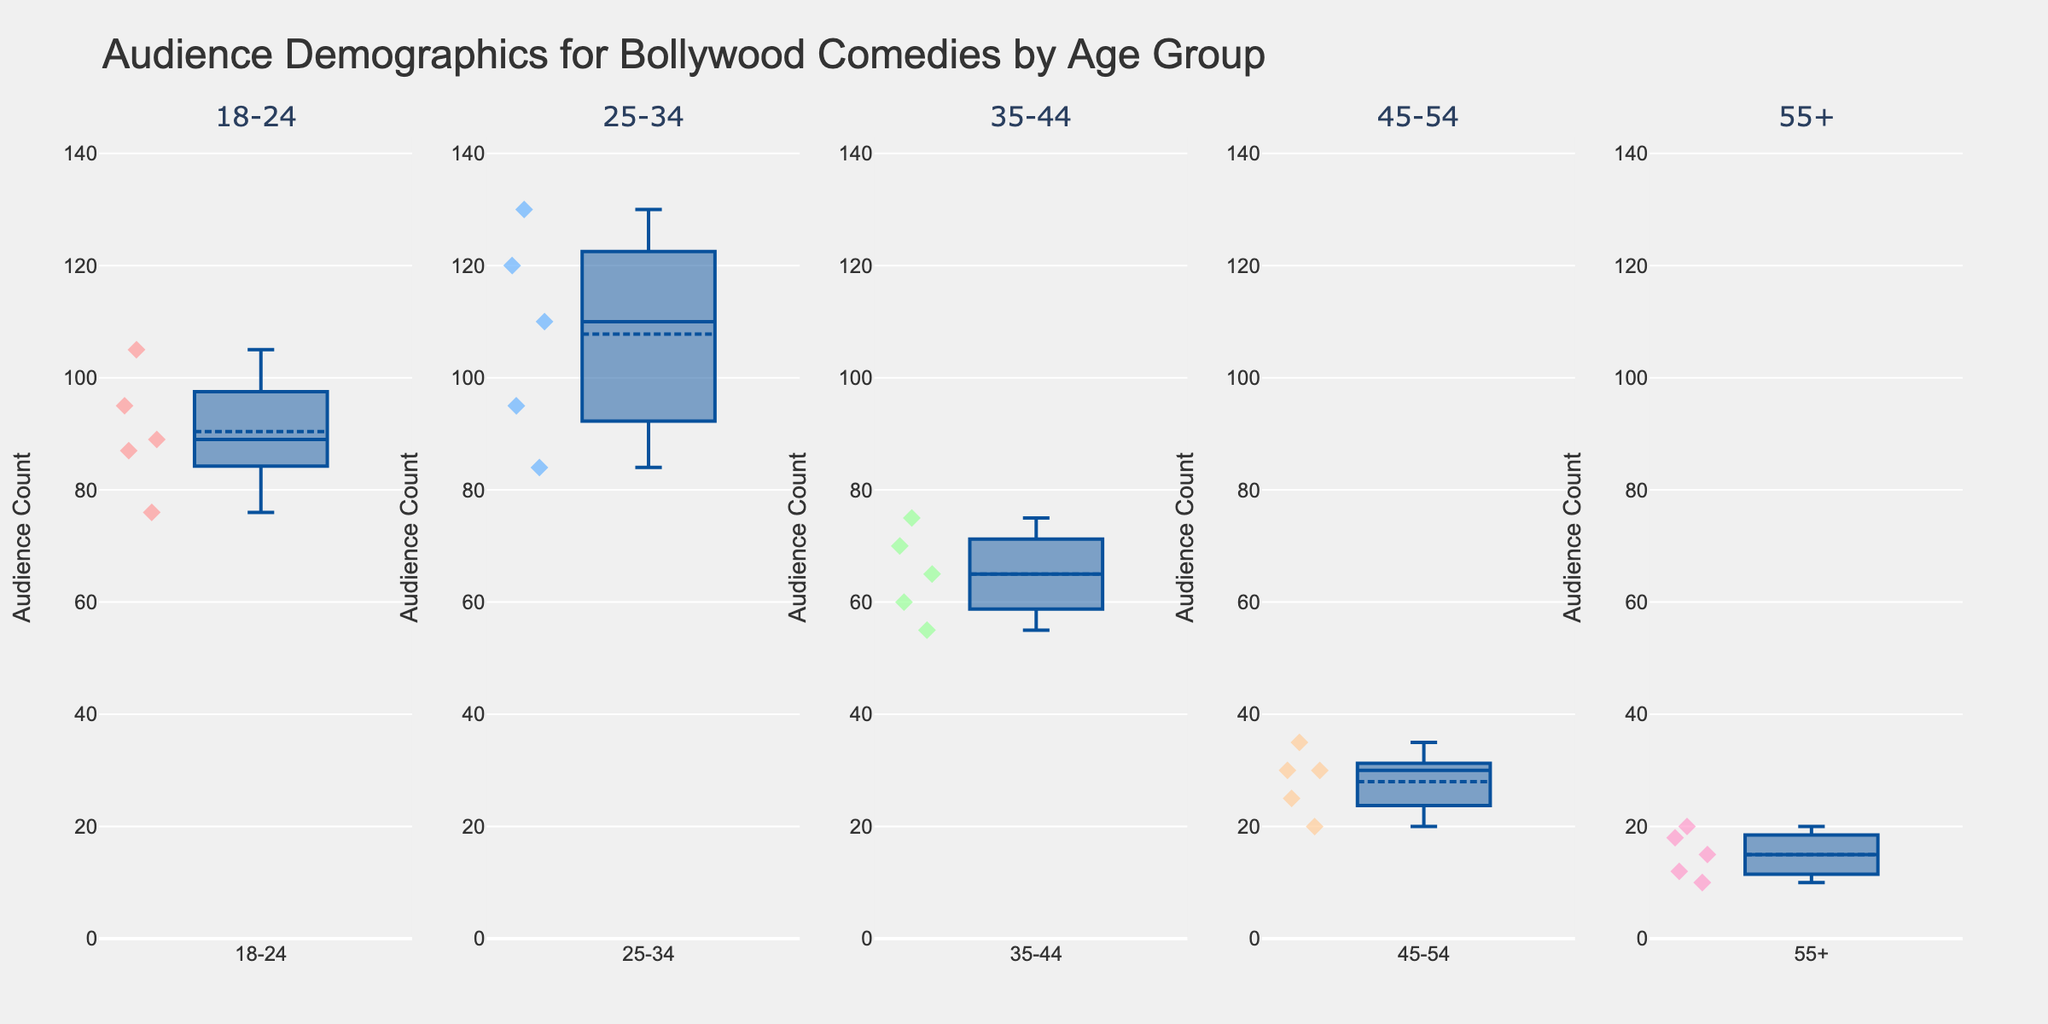What's the title of the figure? The title is typically displayed at the top of the figure. For this plot, the title reads "Audience Demographics for Bollywood Comedies by Age Group."
Answer: Audience Demographics for Bollywood Comedies by Age Group How many subplots are there in the figure? The figure consists of multiple box plots, each representing an age group. You can count the number of distinct age group titles at the top of each subplot.
Answer: 5 Which age group has the highest median audience count? Look at the center line within each box plot, which represents the median. Identify the subplot with the highest median line.
Answer: 25-34 What is the range of audience counts for the movie "Hera Pheri" in the age group 35-44? First, locate the subplot for the 35-44 age group, then find the data points associated with "Hera Pheri" within that plot. Identify the minimum and maximum values of those data points.
Answer: 70 Which age group has the smallest interquartile range (IQR)? The IQR is the range between the first quartile (Q1) and the third quartile (Q3) in each box plot. Look for the box plot with the smallest distance between these two lines.
Answer: 55+ How does the average audience count of "3 Idiots" compare between age groups 18-24 and 25-34? Locate the specific data points for "3 Idiots" in both the 18-24 and 25-34 plots. Calculate or note down the individual audience counts and compare them.
Answer: Higher in 25-34 What is the whisker width used in the figure? Observe the whiskers, the lines that extend from the box to the highest and lowest data points within a specified range. The width can be determined by their standard appearance in the box plots.
Answer: 0.2 How does the variability of audience counts for "Bhool Bhulaiyaa" differ between age groups 45-54 and 55+? Look at the spread of the data points for "Bhool Bhulaiyaa" in the 45-54 and 55+ age group plots. Compare the ranges, quartiles, and spread of values.
Answer: More variable in 45-54 Which movie has the most consistent audience count across all age groups? Consistency can be assessed by comparing the variability (spread) of data points for each movie across all age groups. A movie with little spread has more consistent audience counts.
Answer: Bhool Bhulaiyaa What is the audience count of the most popular movie among seniors (55+)? Focus on the subplot for the 55+ age group and identify the movie with the highest data point.
Answer: Hera Pheri 